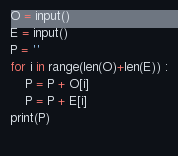Convert code to text. <code><loc_0><loc_0><loc_500><loc_500><_Python_>O = input()
E = input()
P = ''
for i in range(len(O)+len(E)) :
    P = P + O[i]
    P = P + E[i]
print(P)
    </code> 